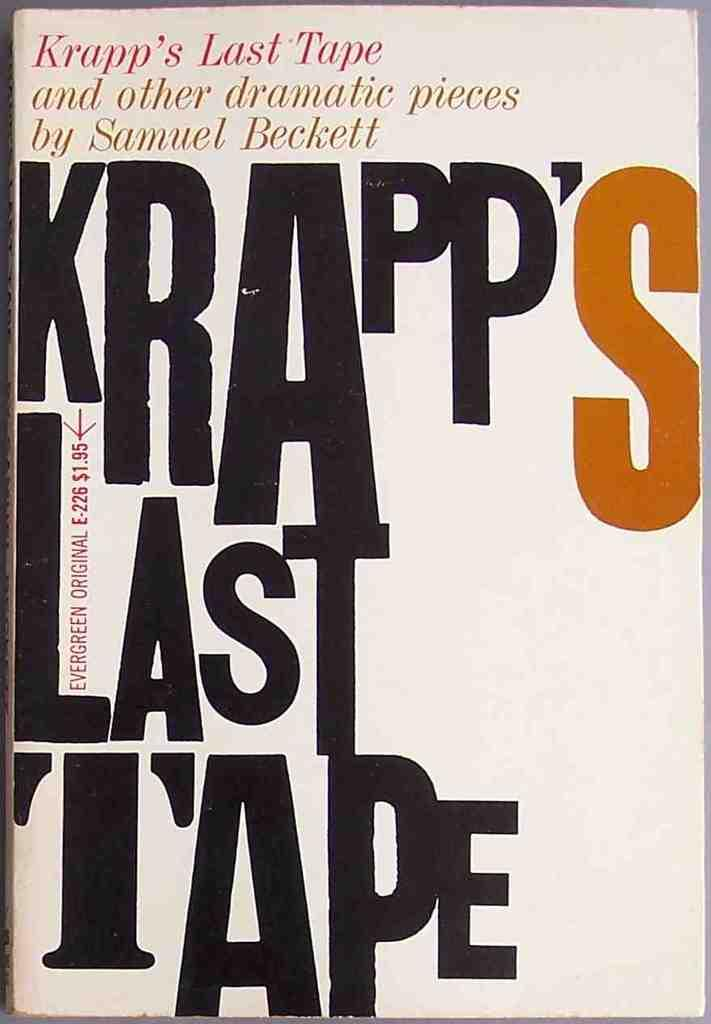<image>
Offer a succinct explanation of the picture presented. A book cover for a book by Samuel Beckett. 